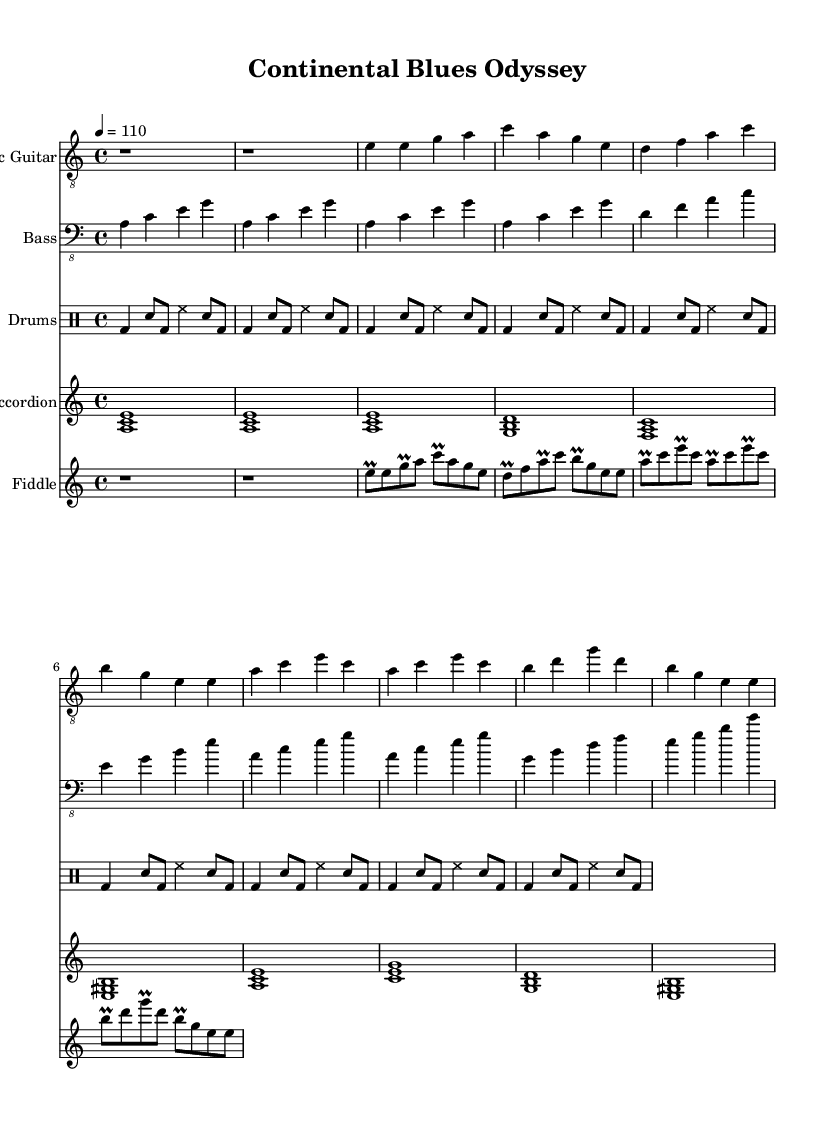What is the key signature of this music? The key signature is indicated at the beginning of the sheet music. It shows an A minor key signature, which has no sharps or flats.
Answer: A minor What is the time signature of the piece? The time signature is displayed at the beginning of the sheet music just after the key signature. It reads 4/4, indicating four beats per measure.
Answer: 4/4 What is the tempo marking for this piece? The tempo marking follows the time signature in the sheet music. It indicates a tempo of 110 beats per minute, suggesting a moderate pace for performance.
Answer: 110 How many measures are in the Intro section? The Intro section consists of two measures, as indicated by the two sets of rest (r1) symbols in the electric guitar part.
Answer: 2 What instrument plays the first chord in the Intro? The first chord shown in the Intro is played by the accordion, indicated by the chord notation at the beginning of the accordion part.
Answer: Accordion In which section does the Electric Guitar play the note 'g' after 'e'? The Electric Guitar plays the note 'g' immediately after the note 'e' in the first verse, indicated by the sequence of notes in the electric guitar's part.
Answer: Verse 1 What instruments contribute to the rhythm section in this piece? The rhythm section is comprised of the Bass Guitar and Drums, as these instruments provide the foundational groove and syncopation throughout the piece.
Answer: Bass Guitar and Drums 